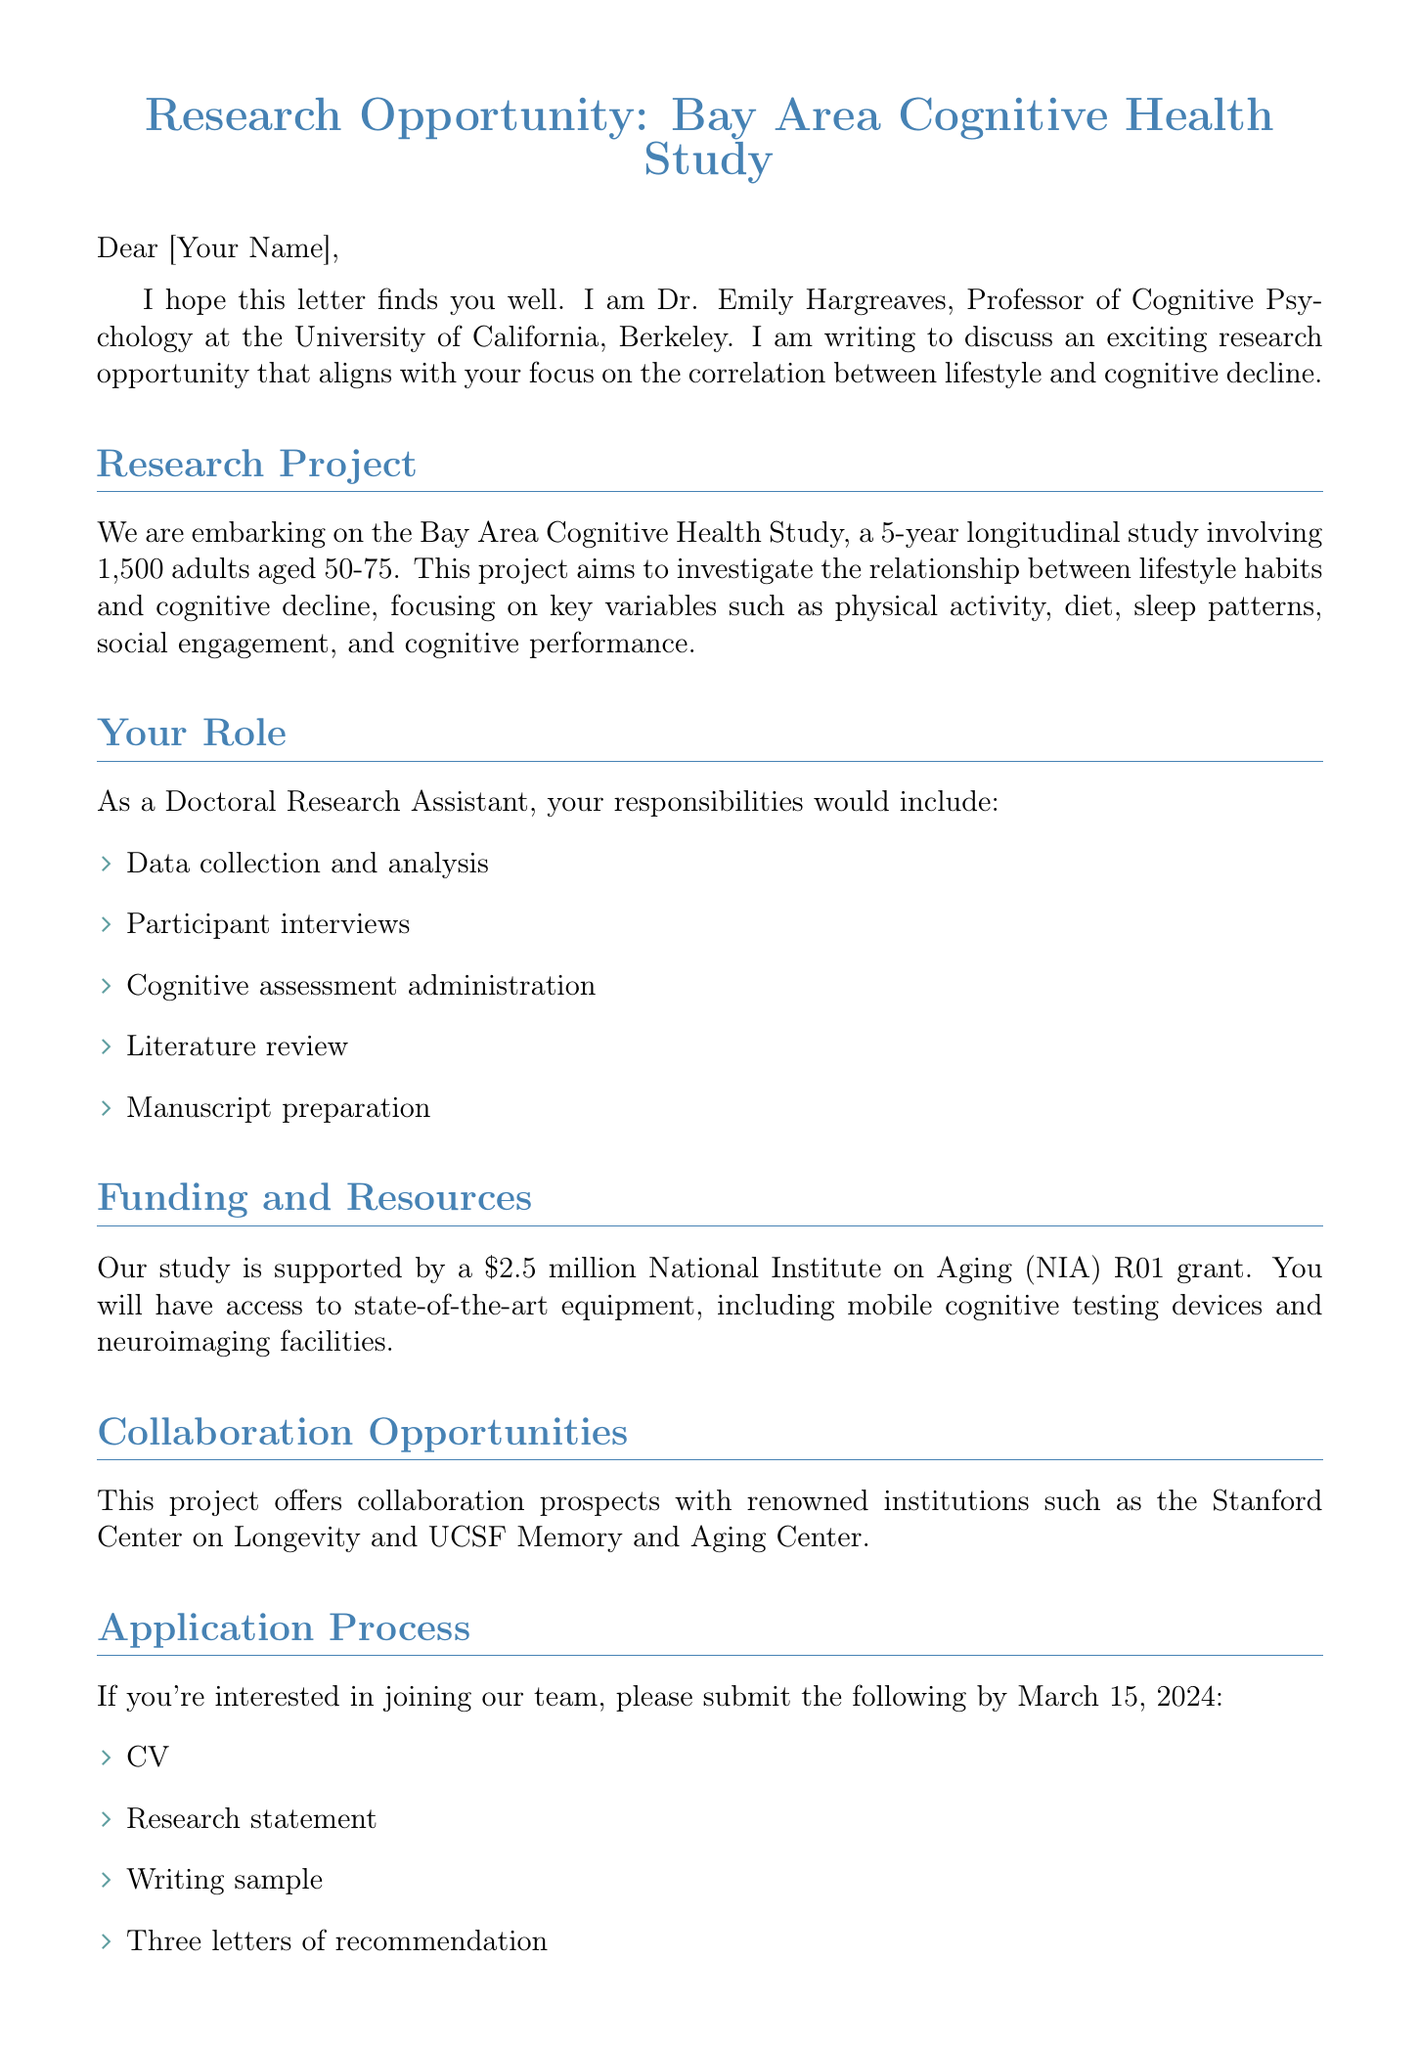What is the name of the advisor? The advisor's name is mentioned in the introduction section of the document.
Answer: Dr. Emily Hargreaves What is the project duration? The duration of the research project is specified in the research opportunity section.
Answer: 5-year longitudinal study How many participants are involved in the study? The number of participants is outlined in the research opportunity details.
Answer: 1,500 adults What are the key variables in the study? The document lists key variables that will be examined in the research project.
Answer: Physical activity, Diet, Sleep patterns, Social engagement, Cognitive performance What is the funding amount of the grant? The funding information is provided under the funding and resources section.
Answer: $2.5 million When is the application deadline? The application deadline is explicitly stated in the next steps section.
Answer: March 15, 2024 What position will you be applying for? The role you are applying for is mentioned in the your role section.
Answer: Doctoral Research Assistant What institutions will you have collaboration opportunities with? The collaboration opportunities are specified in the collaboration opportunities section.
Answer: Stanford Center on Longevity, UCSF Memory and Aging Center How many letters of recommendation are required? The required materials for the application include specific document types as listed in the application process.
Answer: Three letters of recommendation 